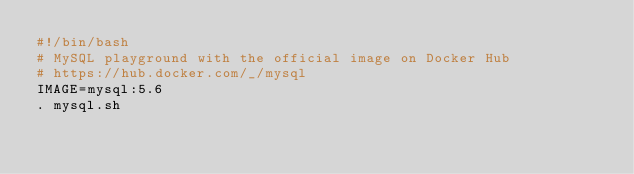Convert code to text. <code><loc_0><loc_0><loc_500><loc_500><_Bash_>#!/bin/bash
# MySQL playground with the official image on Docker Hub
# https://hub.docker.com/_/mysql
IMAGE=mysql:5.6
. mysql.sh
</code> 